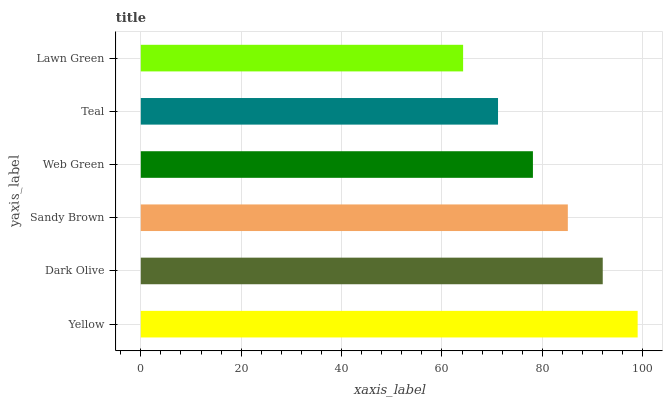Is Lawn Green the minimum?
Answer yes or no. Yes. Is Yellow the maximum?
Answer yes or no. Yes. Is Dark Olive the minimum?
Answer yes or no. No. Is Dark Olive the maximum?
Answer yes or no. No. Is Yellow greater than Dark Olive?
Answer yes or no. Yes. Is Dark Olive less than Yellow?
Answer yes or no. Yes. Is Dark Olive greater than Yellow?
Answer yes or no. No. Is Yellow less than Dark Olive?
Answer yes or no. No. Is Sandy Brown the high median?
Answer yes or no. Yes. Is Web Green the low median?
Answer yes or no. Yes. Is Web Green the high median?
Answer yes or no. No. Is Yellow the low median?
Answer yes or no. No. 